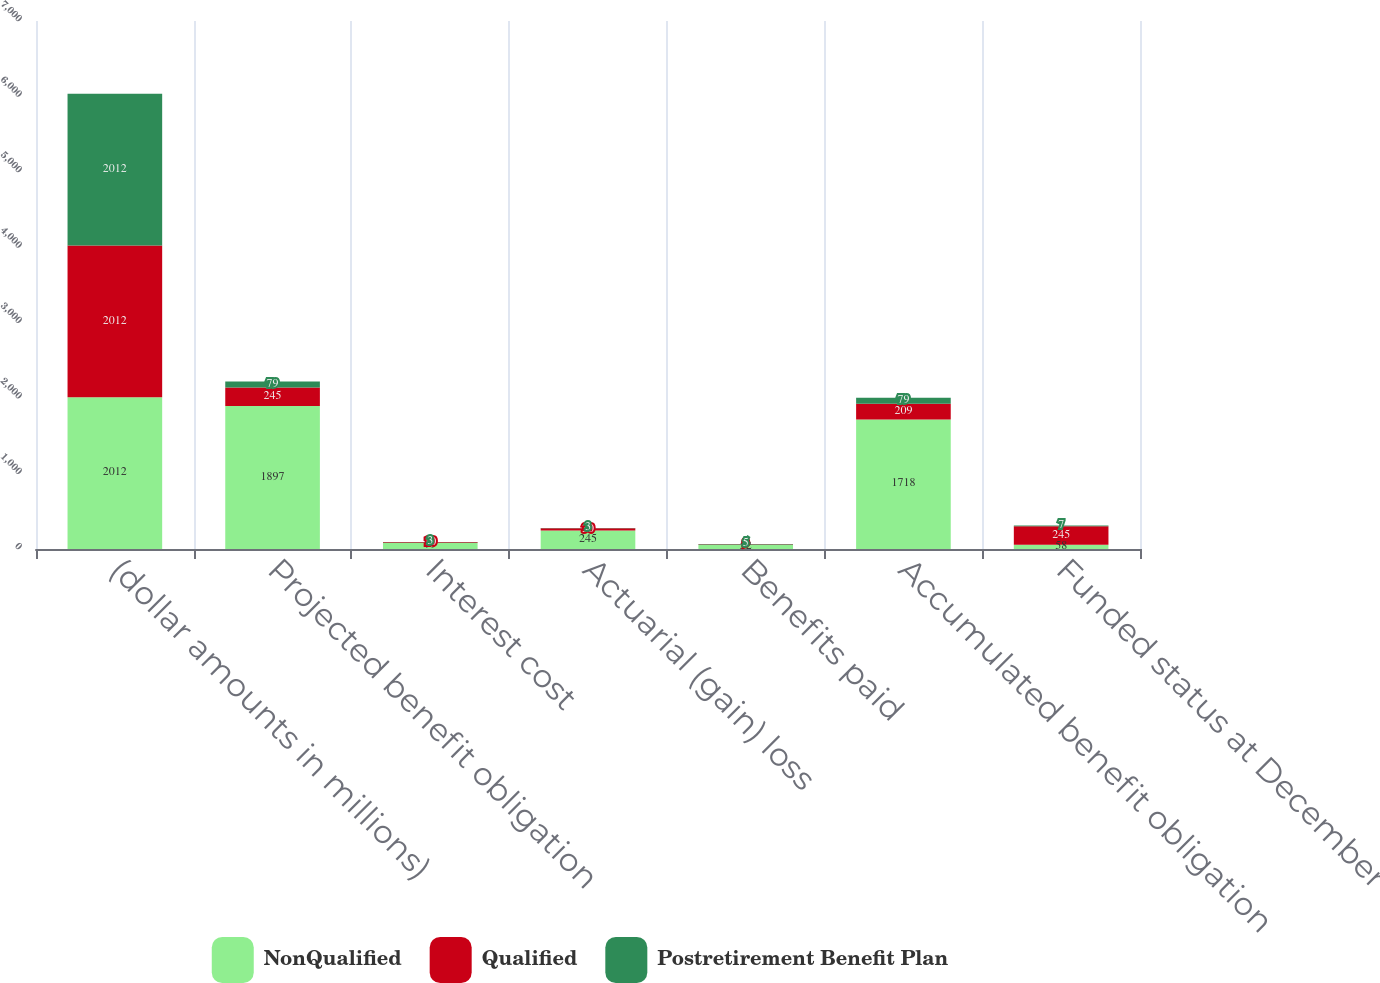<chart> <loc_0><loc_0><loc_500><loc_500><stacked_bar_chart><ecel><fcel>(dollar amounts in millions)<fcel>Projected benefit obligation<fcel>Interest cost<fcel>Actuarial (gain) loss<fcel>Benefits paid<fcel>Accumulated benefit obligation<fcel>Funded status at December 31<nl><fcel>NonQualified<fcel>2012<fcel>1897<fcel>79<fcel>245<fcel>52<fcel>1718<fcel>58<nl><fcel>Qualified<fcel>2012<fcel>245<fcel>10<fcel>30<fcel>9<fcel>209<fcel>245<nl><fcel>Postretirement Benefit Plan<fcel>2012<fcel>79<fcel>3<fcel>3<fcel>5<fcel>79<fcel>7<nl></chart> 